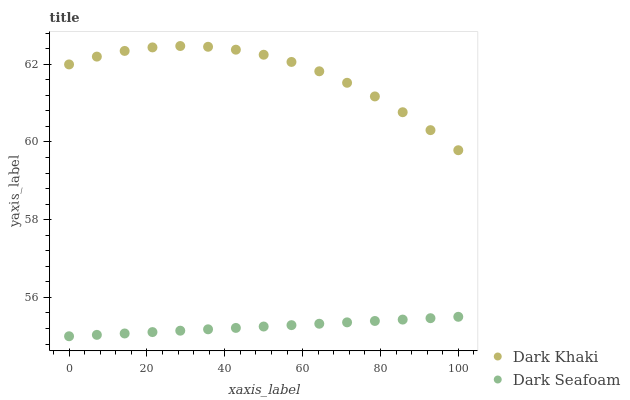Does Dark Seafoam have the minimum area under the curve?
Answer yes or no. Yes. Does Dark Khaki have the maximum area under the curve?
Answer yes or no. Yes. Does Dark Seafoam have the maximum area under the curve?
Answer yes or no. No. Is Dark Seafoam the smoothest?
Answer yes or no. Yes. Is Dark Khaki the roughest?
Answer yes or no. Yes. Is Dark Seafoam the roughest?
Answer yes or no. No. Does Dark Seafoam have the lowest value?
Answer yes or no. Yes. Does Dark Khaki have the highest value?
Answer yes or no. Yes. Does Dark Seafoam have the highest value?
Answer yes or no. No. Is Dark Seafoam less than Dark Khaki?
Answer yes or no. Yes. Is Dark Khaki greater than Dark Seafoam?
Answer yes or no. Yes. Does Dark Seafoam intersect Dark Khaki?
Answer yes or no. No. 